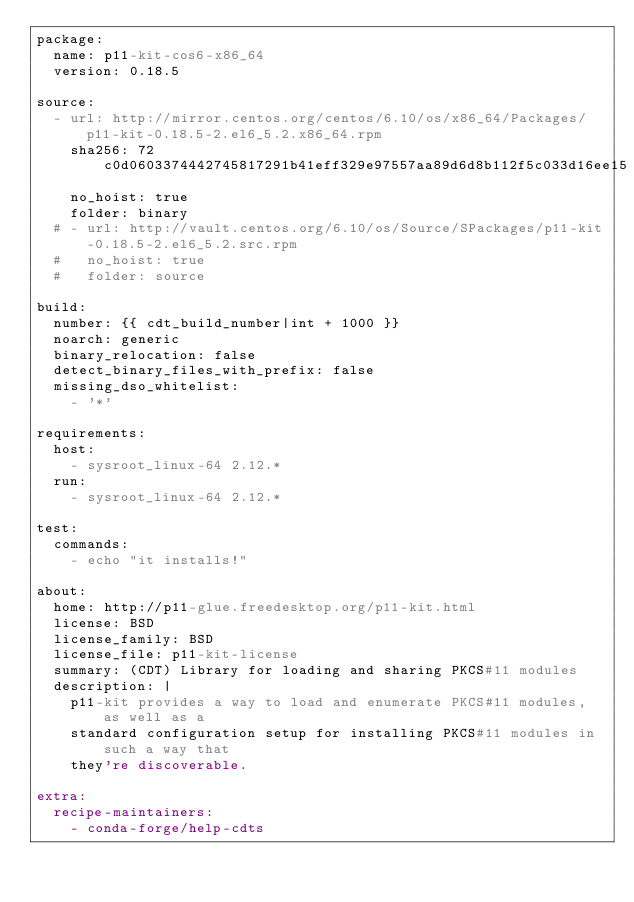<code> <loc_0><loc_0><loc_500><loc_500><_YAML_>package:
  name: p11-kit-cos6-x86_64
  version: 0.18.5

source:
  - url: http://mirror.centos.org/centos/6.10/os/x86_64/Packages/p11-kit-0.18.5-2.el6_5.2.x86_64.rpm
    sha256: 72c0d0603374442745817291b41eff329e97557aa89d6d8b112f5c033d16ee15
    no_hoist: true
    folder: binary
  # - url: http://vault.centos.org/6.10/os/Source/SPackages/p11-kit-0.18.5-2.el6_5.2.src.rpm
  #   no_hoist: true
  #   folder: source

build:
  number: {{ cdt_build_number|int + 1000 }}
  noarch: generic
  binary_relocation: false
  detect_binary_files_with_prefix: false
  missing_dso_whitelist:
    - '*'

requirements:
  host:
    - sysroot_linux-64 2.12.*
  run:
    - sysroot_linux-64 2.12.*

test:
  commands:
    - echo "it installs!"

about:
  home: http://p11-glue.freedesktop.org/p11-kit.html
  license: BSD
  license_family: BSD
  license_file: p11-kit-license
  summary: (CDT) Library for loading and sharing PKCS#11 modules
  description: |
    p11-kit provides a way to load and enumerate PKCS#11 modules, as well as a
    standard configuration setup for installing PKCS#11 modules in such a way that
    they're discoverable.

extra:
  recipe-maintainers:
    - conda-forge/help-cdts
</code> 